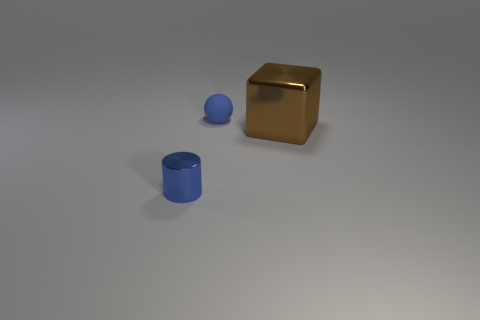How many cubes are either blue objects or big gray things?
Make the answer very short. 0. Are any green shiny things visible?
Keep it short and to the point. No. What number of other things are the same material as the tiny blue cylinder?
Make the answer very short. 1. There is a blue cylinder that is the same size as the sphere; what is it made of?
Make the answer very short. Metal. There is a shiny object on the left side of the tiny blue ball; is its shape the same as the brown thing?
Provide a succinct answer. No. Is the color of the big metallic thing the same as the small rubber thing?
Your answer should be very brief. No. How many things are blue things that are behind the brown block or tiny blue matte spheres?
Keep it short and to the point. 1. What is the shape of the other blue object that is the same size as the blue shiny object?
Give a very brief answer. Sphere. There is a metal object to the right of the tiny cylinder; is it the same size as the blue thing that is in front of the tiny blue sphere?
Offer a very short reply. No. The thing that is made of the same material as the cube is what color?
Offer a terse response. Blue. 